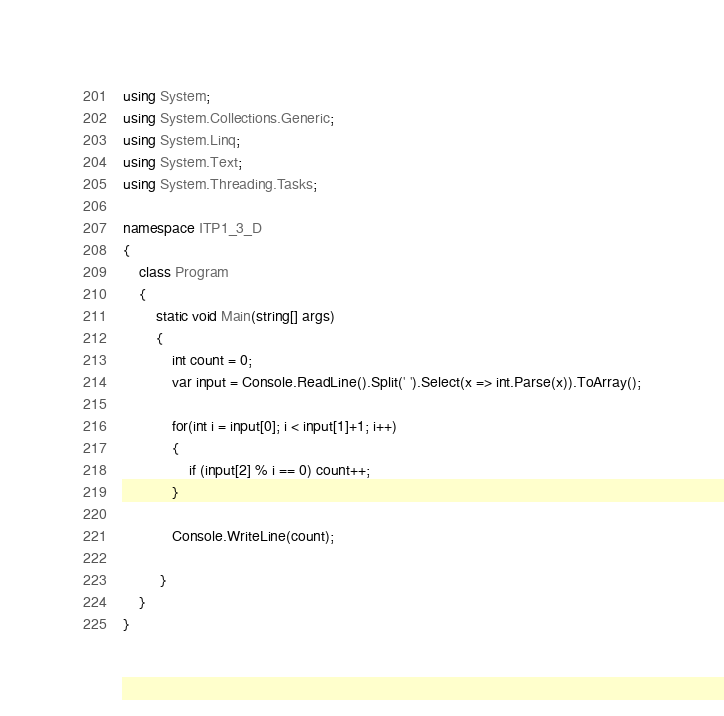Convert code to text. <code><loc_0><loc_0><loc_500><loc_500><_C#_>using System;
using System.Collections.Generic;
using System.Linq;
using System.Text;
using System.Threading.Tasks;

namespace ITP1_3_D
{
    class Program
    {
        static void Main(string[] args)
        {
            int count = 0;
            var input = Console.ReadLine().Split(' ').Select(x => int.Parse(x)).ToArray();

            for(int i = input[0]; i < input[1]+1; i++)
            {
                if (input[2] % i == 0) count++;
            }

            Console.WriteLine(count);
                
         }
    }
}

</code> 